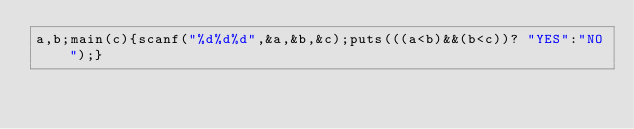Convert code to text. <code><loc_0><loc_0><loc_500><loc_500><_C_>a,b;main(c){scanf("%d%d%d",&a,&b,&c);puts(((a<b)&&(b<c))? "YES":"NO");}</code> 